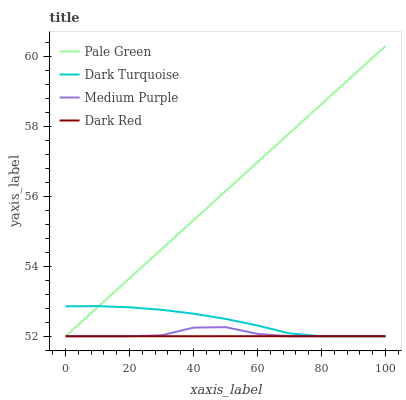Does Dark Red have the minimum area under the curve?
Answer yes or no. Yes. Does Pale Green have the maximum area under the curve?
Answer yes or no. Yes. Does Dark Turquoise have the minimum area under the curve?
Answer yes or no. No. Does Dark Turquoise have the maximum area under the curve?
Answer yes or no. No. Is Pale Green the smoothest?
Answer yes or no. Yes. Is Medium Purple the roughest?
Answer yes or no. Yes. Is Dark Turquoise the smoothest?
Answer yes or no. No. Is Dark Turquoise the roughest?
Answer yes or no. No. Does Medium Purple have the lowest value?
Answer yes or no. Yes. Does Pale Green have the highest value?
Answer yes or no. Yes. Does Dark Turquoise have the highest value?
Answer yes or no. No. Does Dark Red intersect Medium Purple?
Answer yes or no. Yes. Is Dark Red less than Medium Purple?
Answer yes or no. No. Is Dark Red greater than Medium Purple?
Answer yes or no. No. 